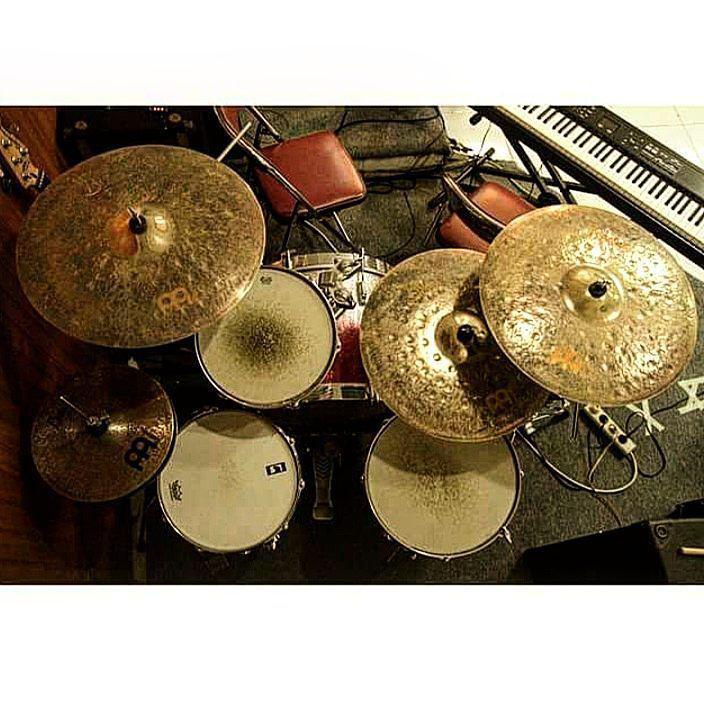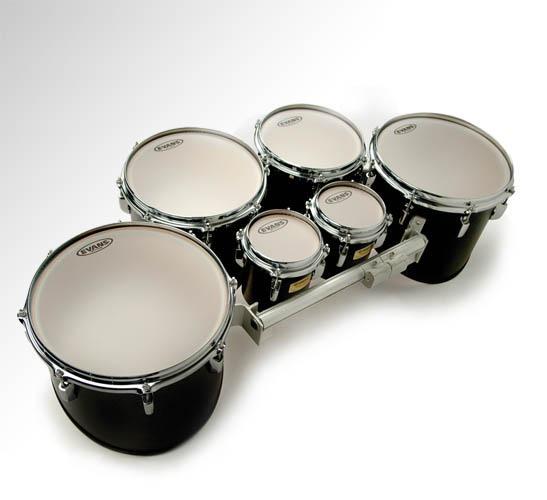The first image is the image on the left, the second image is the image on the right. Analyze the images presented: Is the assertion "The right image shows a row of at least three white-topped drums with black around at least part of their sides and no cymbals." valid? Answer yes or no. Yes. 